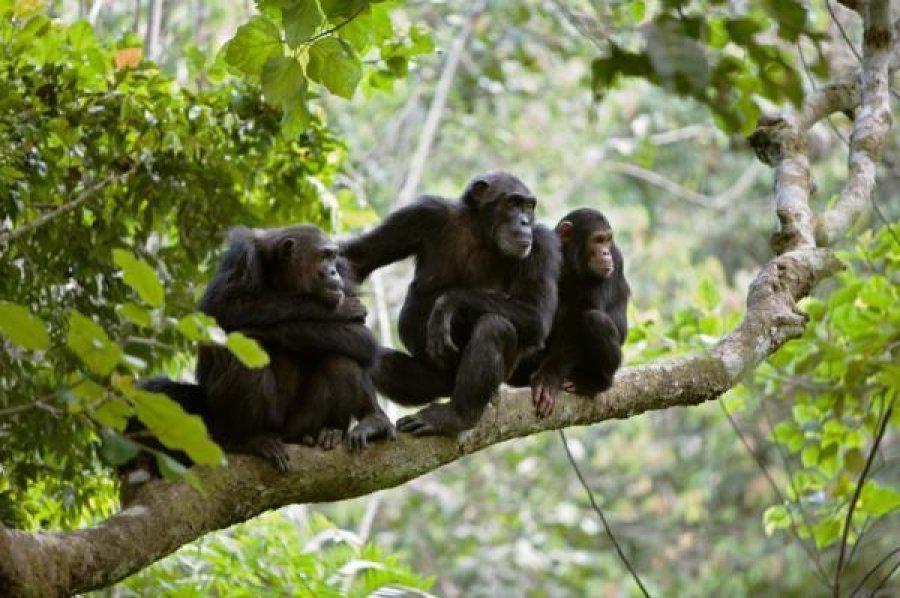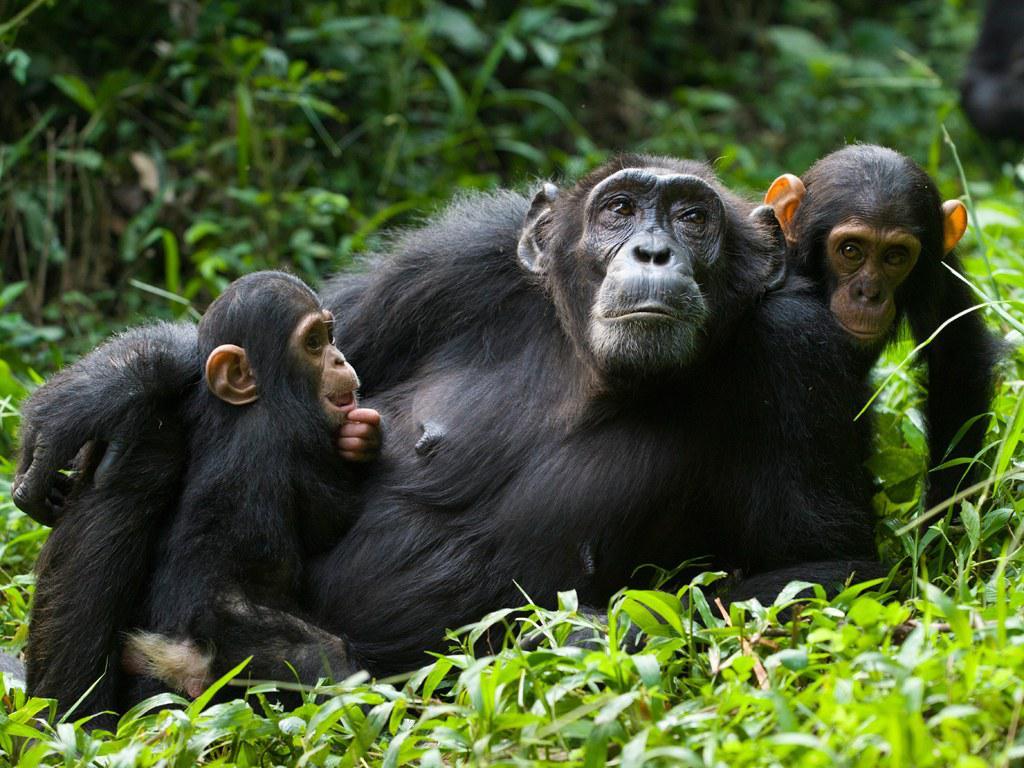The first image is the image on the left, the second image is the image on the right. For the images displayed, is the sentence "An image shows a trio of chimps in a row up off the ground on something branch-like." factually correct? Answer yes or no. Yes. The first image is the image on the left, the second image is the image on the right. Evaluate the accuracy of this statement regarding the images: "Some apes are holding food in their hands.". Is it true? Answer yes or no. No. 